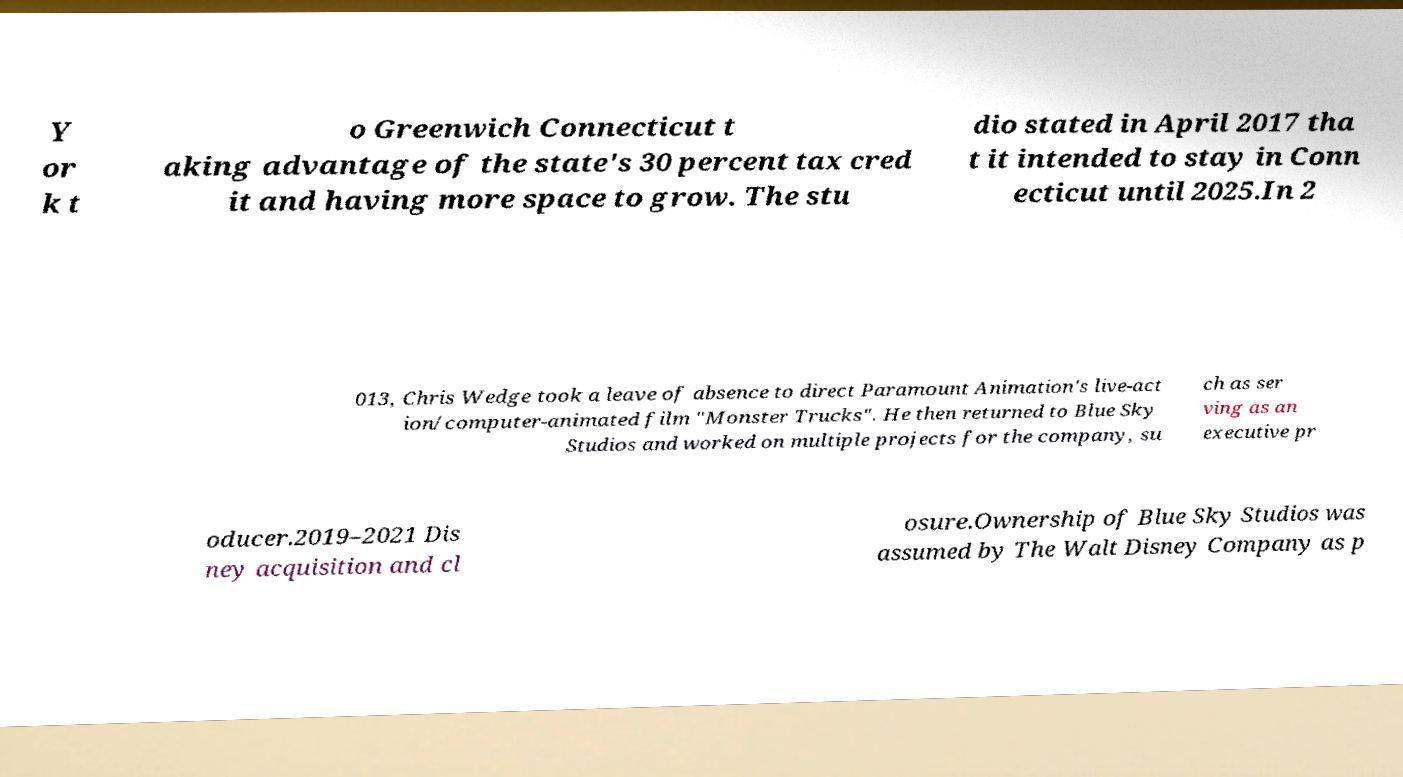Could you extract and type out the text from this image? Y or k t o Greenwich Connecticut t aking advantage of the state's 30 percent tax cred it and having more space to grow. The stu dio stated in April 2017 tha t it intended to stay in Conn ecticut until 2025.In 2 013, Chris Wedge took a leave of absence to direct Paramount Animation's live-act ion/computer-animated film "Monster Trucks". He then returned to Blue Sky Studios and worked on multiple projects for the company, su ch as ser ving as an executive pr oducer.2019–2021 Dis ney acquisition and cl osure.Ownership of Blue Sky Studios was assumed by The Walt Disney Company as p 